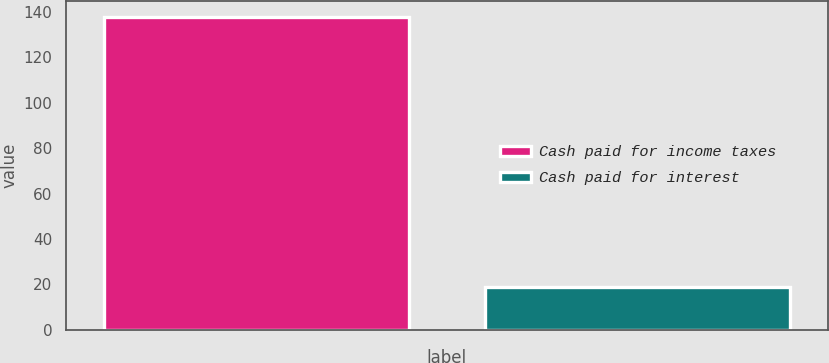<chart> <loc_0><loc_0><loc_500><loc_500><bar_chart><fcel>Cash paid for income taxes<fcel>Cash paid for interest<nl><fcel>138<fcel>19<nl></chart> 